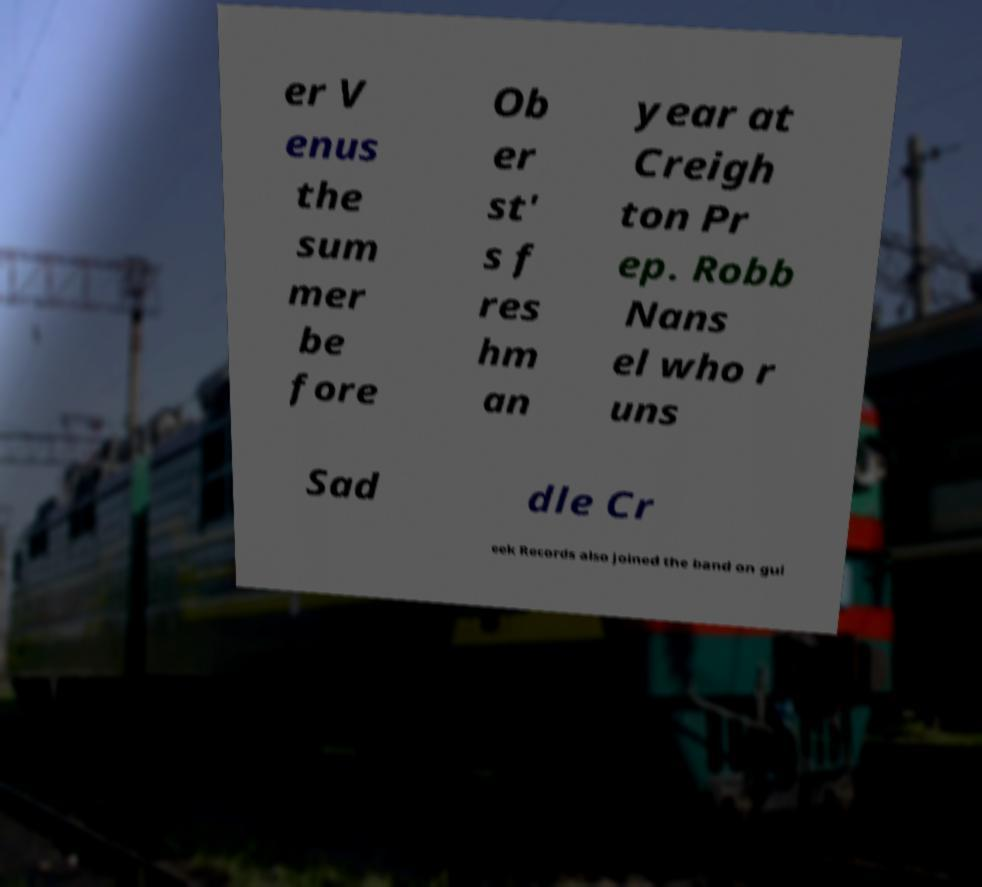Could you extract and type out the text from this image? er V enus the sum mer be fore Ob er st' s f res hm an year at Creigh ton Pr ep. Robb Nans el who r uns Sad dle Cr eek Records also joined the band on gui 